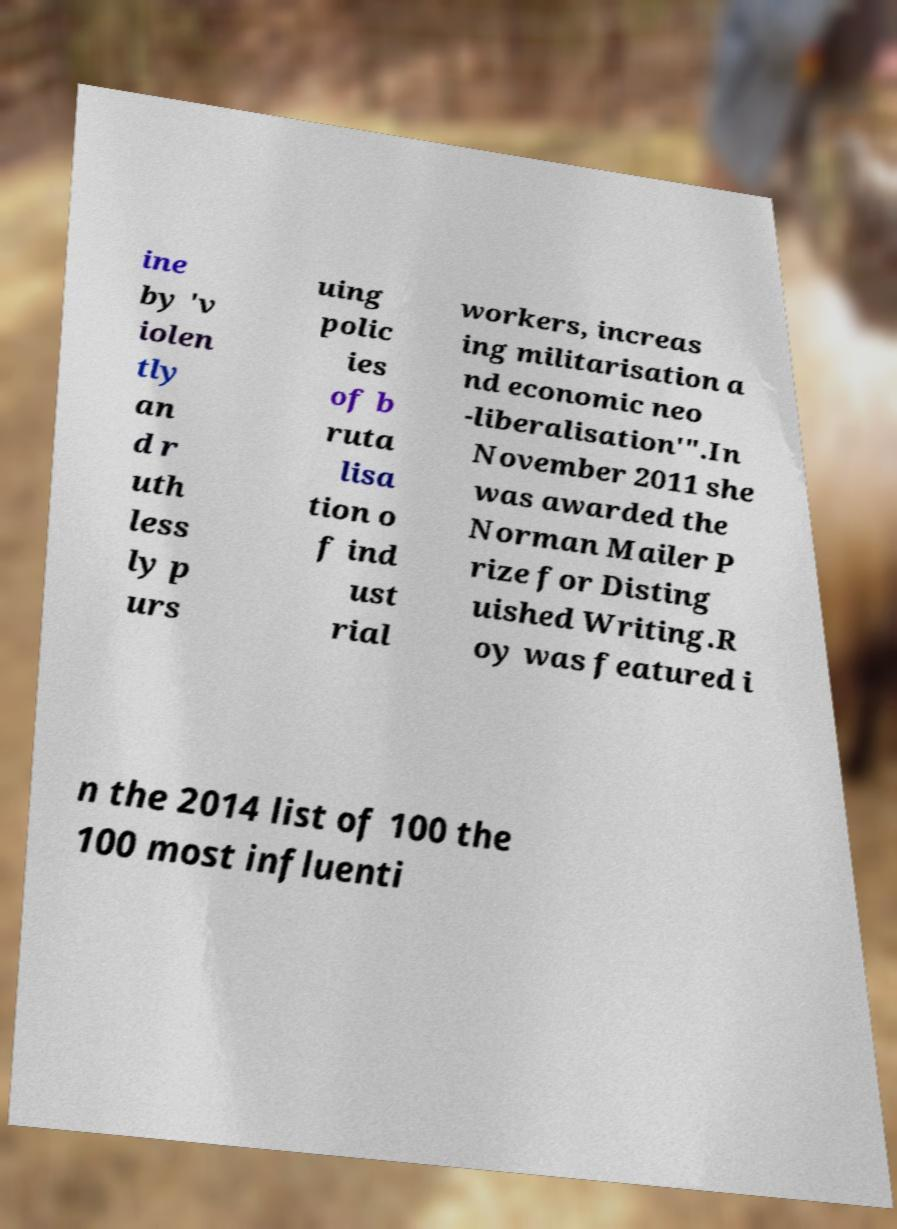Could you assist in decoding the text presented in this image and type it out clearly? ine by 'v iolen tly an d r uth less ly p urs uing polic ies of b ruta lisa tion o f ind ust rial workers, increas ing militarisation a nd economic neo -liberalisation'".In November 2011 she was awarded the Norman Mailer P rize for Disting uished Writing.R oy was featured i n the 2014 list of 100 the 100 most influenti 